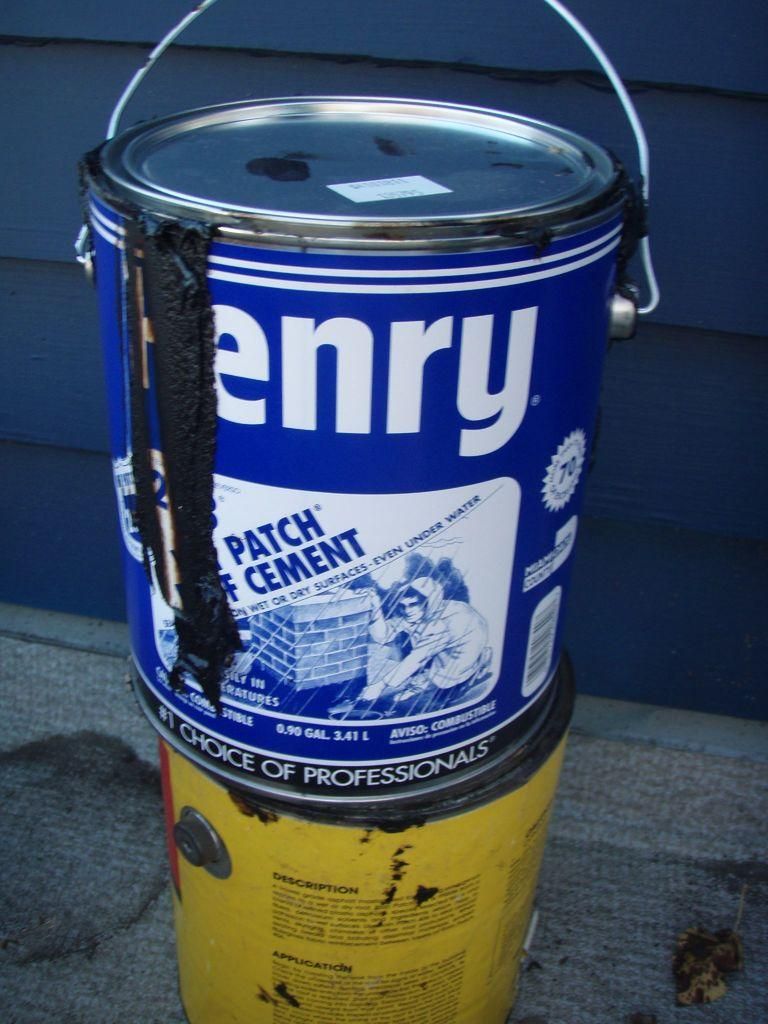What objects are located in the foreground of the image? There are buckets in the foreground of the image. What type of floor can be seen in the image? There is no information about the floor in the image, as the fact provided only mentions the presence of buckets in the foreground. 